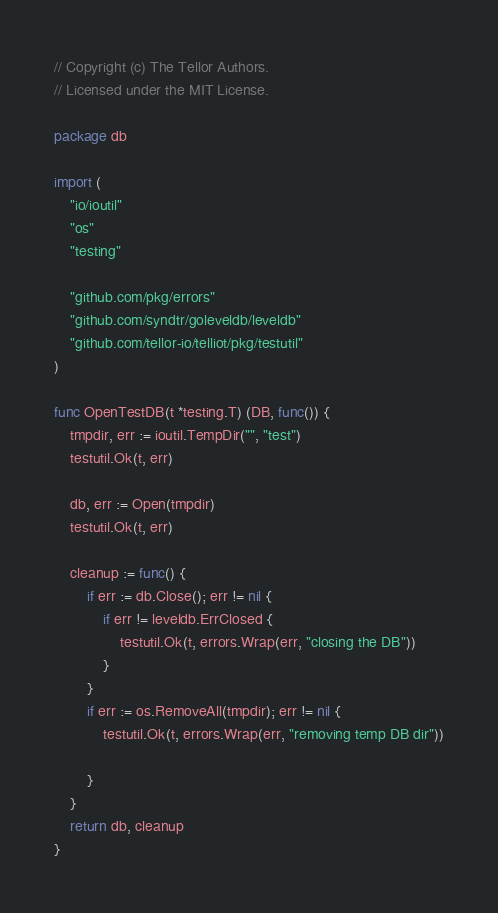<code> <loc_0><loc_0><loc_500><loc_500><_Go_>// Copyright (c) The Tellor Authors.
// Licensed under the MIT License.

package db

import (
	"io/ioutil"
	"os"
	"testing"

	"github.com/pkg/errors"
	"github.com/syndtr/goleveldb/leveldb"
	"github.com/tellor-io/telliot/pkg/testutil"
)

func OpenTestDB(t *testing.T) (DB, func()) {
	tmpdir, err := ioutil.TempDir("", "test")
	testutil.Ok(t, err)

	db, err := Open(tmpdir)
	testutil.Ok(t, err)

	cleanup := func() {
		if err := db.Close(); err != nil {
			if err != leveldb.ErrClosed {
				testutil.Ok(t, errors.Wrap(err, "closing the DB"))
			}
		}
		if err := os.RemoveAll(tmpdir); err != nil {
			testutil.Ok(t, errors.Wrap(err, "removing temp DB dir"))

		}
	}
	return db, cleanup
}
</code> 